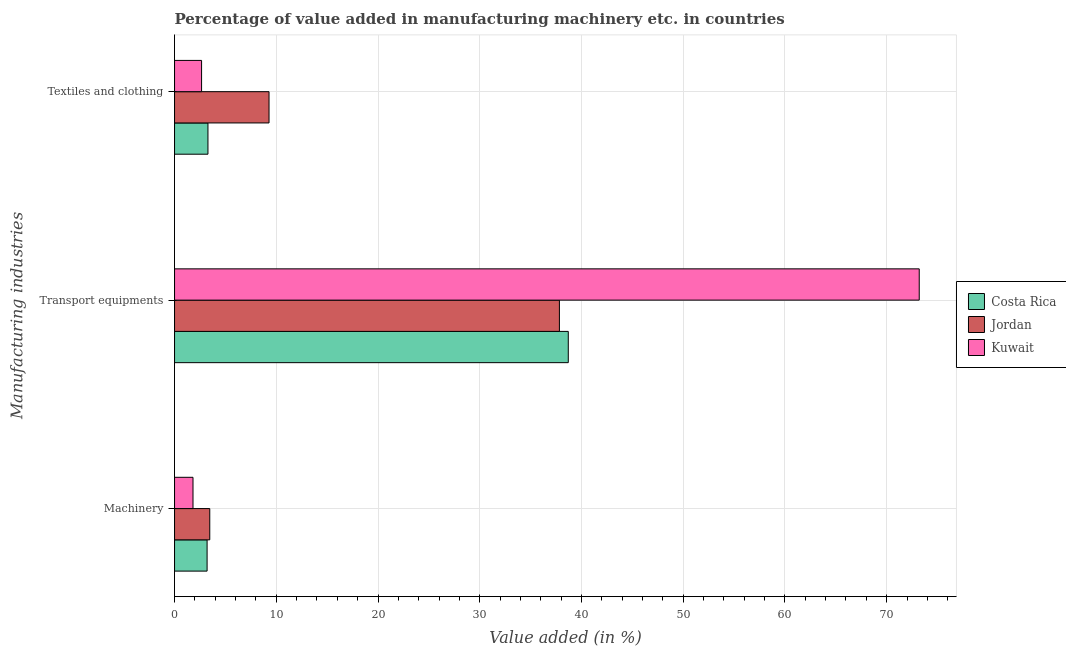How many different coloured bars are there?
Give a very brief answer. 3. How many groups of bars are there?
Your response must be concise. 3. Are the number of bars per tick equal to the number of legend labels?
Give a very brief answer. Yes. Are the number of bars on each tick of the Y-axis equal?
Offer a terse response. Yes. How many bars are there on the 1st tick from the bottom?
Provide a short and direct response. 3. What is the label of the 3rd group of bars from the top?
Offer a terse response. Machinery. What is the value added in manufacturing textile and clothing in Jordan?
Ensure brevity in your answer.  9.29. Across all countries, what is the maximum value added in manufacturing machinery?
Your answer should be very brief. 3.46. Across all countries, what is the minimum value added in manufacturing transport equipments?
Offer a very short reply. 37.83. In which country was the value added in manufacturing textile and clothing maximum?
Ensure brevity in your answer.  Jordan. In which country was the value added in manufacturing machinery minimum?
Keep it short and to the point. Kuwait. What is the total value added in manufacturing machinery in the graph?
Your answer should be very brief. 8.47. What is the difference between the value added in manufacturing machinery in Kuwait and that in Costa Rica?
Your response must be concise. -1.38. What is the difference between the value added in manufacturing machinery in Kuwait and the value added in manufacturing transport equipments in Jordan?
Keep it short and to the point. -36.02. What is the average value added in manufacturing transport equipments per country?
Give a very brief answer. 49.91. What is the difference between the value added in manufacturing machinery and value added in manufacturing transport equipments in Costa Rica?
Your answer should be compact. -35.51. In how many countries, is the value added in manufacturing textile and clothing greater than 28 %?
Provide a succinct answer. 0. What is the ratio of the value added in manufacturing textile and clothing in Costa Rica to that in Jordan?
Your response must be concise. 0.35. Is the value added in manufacturing textile and clothing in Kuwait less than that in Jordan?
Offer a very short reply. Yes. Is the difference between the value added in manufacturing textile and clothing in Kuwait and Jordan greater than the difference between the value added in manufacturing transport equipments in Kuwait and Jordan?
Offer a very short reply. No. What is the difference between the highest and the second highest value added in manufacturing textile and clothing?
Your answer should be compact. 6. What is the difference between the highest and the lowest value added in manufacturing machinery?
Provide a succinct answer. 1.65. Is the sum of the value added in manufacturing machinery in Costa Rica and Kuwait greater than the maximum value added in manufacturing transport equipments across all countries?
Provide a short and direct response. No. What does the 1st bar from the top in Transport equipments represents?
Ensure brevity in your answer.  Kuwait. What does the 3rd bar from the bottom in Transport equipments represents?
Keep it short and to the point. Kuwait. Are all the bars in the graph horizontal?
Ensure brevity in your answer.  Yes. How many countries are there in the graph?
Make the answer very short. 3. What is the difference between two consecutive major ticks on the X-axis?
Give a very brief answer. 10. Does the graph contain grids?
Make the answer very short. Yes. What is the title of the graph?
Your answer should be very brief. Percentage of value added in manufacturing machinery etc. in countries. What is the label or title of the X-axis?
Provide a short and direct response. Value added (in %). What is the label or title of the Y-axis?
Make the answer very short. Manufacturing industries. What is the Value added (in %) in Costa Rica in Machinery?
Make the answer very short. 3.2. What is the Value added (in %) of Jordan in Machinery?
Offer a very short reply. 3.46. What is the Value added (in %) in Kuwait in Machinery?
Ensure brevity in your answer.  1.81. What is the Value added (in %) of Costa Rica in Transport equipments?
Offer a very short reply. 38.7. What is the Value added (in %) of Jordan in Transport equipments?
Offer a very short reply. 37.83. What is the Value added (in %) of Kuwait in Transport equipments?
Offer a terse response. 73.2. What is the Value added (in %) of Costa Rica in Textiles and clothing?
Offer a very short reply. 3.28. What is the Value added (in %) of Jordan in Textiles and clothing?
Keep it short and to the point. 9.29. What is the Value added (in %) of Kuwait in Textiles and clothing?
Offer a very short reply. 2.66. Across all Manufacturing industries, what is the maximum Value added (in %) in Costa Rica?
Provide a succinct answer. 38.7. Across all Manufacturing industries, what is the maximum Value added (in %) in Jordan?
Your answer should be compact. 37.83. Across all Manufacturing industries, what is the maximum Value added (in %) of Kuwait?
Make the answer very short. 73.2. Across all Manufacturing industries, what is the minimum Value added (in %) of Costa Rica?
Keep it short and to the point. 3.2. Across all Manufacturing industries, what is the minimum Value added (in %) in Jordan?
Your answer should be very brief. 3.46. Across all Manufacturing industries, what is the minimum Value added (in %) in Kuwait?
Provide a short and direct response. 1.81. What is the total Value added (in %) in Costa Rica in the graph?
Your response must be concise. 45.19. What is the total Value added (in %) of Jordan in the graph?
Give a very brief answer. 50.58. What is the total Value added (in %) in Kuwait in the graph?
Offer a very short reply. 77.67. What is the difference between the Value added (in %) of Costa Rica in Machinery and that in Transport equipments?
Provide a succinct answer. -35.51. What is the difference between the Value added (in %) in Jordan in Machinery and that in Transport equipments?
Your answer should be compact. -34.37. What is the difference between the Value added (in %) in Kuwait in Machinery and that in Transport equipments?
Your answer should be compact. -71.39. What is the difference between the Value added (in %) in Costa Rica in Machinery and that in Textiles and clothing?
Your answer should be compact. -0.09. What is the difference between the Value added (in %) in Jordan in Machinery and that in Textiles and clothing?
Provide a short and direct response. -5.83. What is the difference between the Value added (in %) of Kuwait in Machinery and that in Textiles and clothing?
Ensure brevity in your answer.  -0.84. What is the difference between the Value added (in %) in Costa Rica in Transport equipments and that in Textiles and clothing?
Your answer should be compact. 35.42. What is the difference between the Value added (in %) of Jordan in Transport equipments and that in Textiles and clothing?
Offer a terse response. 28.54. What is the difference between the Value added (in %) in Kuwait in Transport equipments and that in Textiles and clothing?
Make the answer very short. 70.54. What is the difference between the Value added (in %) of Costa Rica in Machinery and the Value added (in %) of Jordan in Transport equipments?
Your answer should be compact. -34.63. What is the difference between the Value added (in %) of Costa Rica in Machinery and the Value added (in %) of Kuwait in Transport equipments?
Your response must be concise. -70. What is the difference between the Value added (in %) in Jordan in Machinery and the Value added (in %) in Kuwait in Transport equipments?
Provide a succinct answer. -69.74. What is the difference between the Value added (in %) of Costa Rica in Machinery and the Value added (in %) of Jordan in Textiles and clothing?
Provide a short and direct response. -6.09. What is the difference between the Value added (in %) in Costa Rica in Machinery and the Value added (in %) in Kuwait in Textiles and clothing?
Make the answer very short. 0.54. What is the difference between the Value added (in %) in Jordan in Machinery and the Value added (in %) in Kuwait in Textiles and clothing?
Provide a short and direct response. 0.81. What is the difference between the Value added (in %) in Costa Rica in Transport equipments and the Value added (in %) in Jordan in Textiles and clothing?
Your answer should be very brief. 29.42. What is the difference between the Value added (in %) in Costa Rica in Transport equipments and the Value added (in %) in Kuwait in Textiles and clothing?
Make the answer very short. 36.05. What is the difference between the Value added (in %) of Jordan in Transport equipments and the Value added (in %) of Kuwait in Textiles and clothing?
Provide a succinct answer. 35.17. What is the average Value added (in %) of Costa Rica per Manufacturing industries?
Keep it short and to the point. 15.06. What is the average Value added (in %) in Jordan per Manufacturing industries?
Offer a terse response. 16.86. What is the average Value added (in %) of Kuwait per Manufacturing industries?
Your response must be concise. 25.89. What is the difference between the Value added (in %) in Costa Rica and Value added (in %) in Jordan in Machinery?
Give a very brief answer. -0.26. What is the difference between the Value added (in %) in Costa Rica and Value added (in %) in Kuwait in Machinery?
Give a very brief answer. 1.38. What is the difference between the Value added (in %) of Jordan and Value added (in %) of Kuwait in Machinery?
Offer a terse response. 1.65. What is the difference between the Value added (in %) of Costa Rica and Value added (in %) of Jordan in Transport equipments?
Provide a succinct answer. 0.87. What is the difference between the Value added (in %) in Costa Rica and Value added (in %) in Kuwait in Transport equipments?
Ensure brevity in your answer.  -34.5. What is the difference between the Value added (in %) of Jordan and Value added (in %) of Kuwait in Transport equipments?
Your answer should be very brief. -35.37. What is the difference between the Value added (in %) of Costa Rica and Value added (in %) of Jordan in Textiles and clothing?
Provide a succinct answer. -6. What is the difference between the Value added (in %) of Costa Rica and Value added (in %) of Kuwait in Textiles and clothing?
Provide a short and direct response. 0.63. What is the difference between the Value added (in %) in Jordan and Value added (in %) in Kuwait in Textiles and clothing?
Provide a short and direct response. 6.63. What is the ratio of the Value added (in %) in Costa Rica in Machinery to that in Transport equipments?
Your answer should be compact. 0.08. What is the ratio of the Value added (in %) of Jordan in Machinery to that in Transport equipments?
Offer a terse response. 0.09. What is the ratio of the Value added (in %) of Kuwait in Machinery to that in Transport equipments?
Offer a very short reply. 0.02. What is the ratio of the Value added (in %) in Costa Rica in Machinery to that in Textiles and clothing?
Make the answer very short. 0.97. What is the ratio of the Value added (in %) of Jordan in Machinery to that in Textiles and clothing?
Your response must be concise. 0.37. What is the ratio of the Value added (in %) of Kuwait in Machinery to that in Textiles and clothing?
Your answer should be very brief. 0.68. What is the ratio of the Value added (in %) of Costa Rica in Transport equipments to that in Textiles and clothing?
Keep it short and to the point. 11.79. What is the ratio of the Value added (in %) in Jordan in Transport equipments to that in Textiles and clothing?
Provide a succinct answer. 4.07. What is the ratio of the Value added (in %) of Kuwait in Transport equipments to that in Textiles and clothing?
Your answer should be very brief. 27.55. What is the difference between the highest and the second highest Value added (in %) in Costa Rica?
Offer a terse response. 35.42. What is the difference between the highest and the second highest Value added (in %) of Jordan?
Your answer should be compact. 28.54. What is the difference between the highest and the second highest Value added (in %) in Kuwait?
Ensure brevity in your answer.  70.54. What is the difference between the highest and the lowest Value added (in %) of Costa Rica?
Your response must be concise. 35.51. What is the difference between the highest and the lowest Value added (in %) in Jordan?
Offer a very short reply. 34.37. What is the difference between the highest and the lowest Value added (in %) of Kuwait?
Your response must be concise. 71.39. 